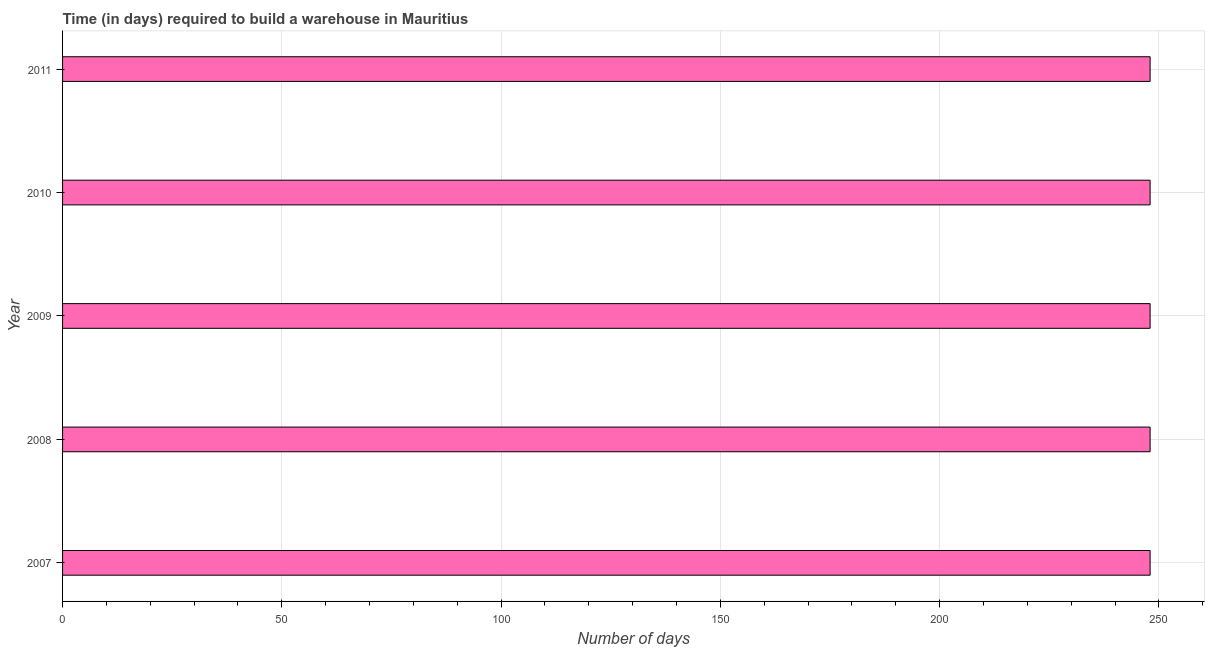Does the graph contain any zero values?
Offer a very short reply. No. Does the graph contain grids?
Offer a very short reply. Yes. What is the title of the graph?
Keep it short and to the point. Time (in days) required to build a warehouse in Mauritius. What is the label or title of the X-axis?
Keep it short and to the point. Number of days. What is the time required to build a warehouse in 2011?
Offer a very short reply. 248. Across all years, what is the maximum time required to build a warehouse?
Offer a terse response. 248. Across all years, what is the minimum time required to build a warehouse?
Your response must be concise. 248. What is the sum of the time required to build a warehouse?
Keep it short and to the point. 1240. What is the difference between the time required to build a warehouse in 2007 and 2009?
Your answer should be compact. 0. What is the average time required to build a warehouse per year?
Your answer should be very brief. 248. What is the median time required to build a warehouse?
Give a very brief answer. 248. Do a majority of the years between 2007 and 2010 (inclusive) have time required to build a warehouse greater than 230 days?
Provide a short and direct response. Yes. What is the ratio of the time required to build a warehouse in 2009 to that in 2011?
Your answer should be compact. 1. Is the difference between the time required to build a warehouse in 2009 and 2011 greater than the difference between any two years?
Give a very brief answer. Yes. Is the sum of the time required to build a warehouse in 2010 and 2011 greater than the maximum time required to build a warehouse across all years?
Ensure brevity in your answer.  Yes. What is the difference between the highest and the lowest time required to build a warehouse?
Offer a very short reply. 0. In how many years, is the time required to build a warehouse greater than the average time required to build a warehouse taken over all years?
Offer a terse response. 0. How many bars are there?
Offer a very short reply. 5. What is the Number of days in 2007?
Your answer should be very brief. 248. What is the Number of days in 2008?
Make the answer very short. 248. What is the Number of days in 2009?
Provide a succinct answer. 248. What is the Number of days of 2010?
Offer a very short reply. 248. What is the Number of days in 2011?
Offer a terse response. 248. What is the difference between the Number of days in 2007 and 2008?
Give a very brief answer. 0. What is the difference between the Number of days in 2007 and 2009?
Make the answer very short. 0. What is the difference between the Number of days in 2007 and 2010?
Make the answer very short. 0. What is the difference between the Number of days in 2007 and 2011?
Your answer should be compact. 0. What is the difference between the Number of days in 2008 and 2009?
Give a very brief answer. 0. What is the difference between the Number of days in 2008 and 2010?
Provide a short and direct response. 0. What is the difference between the Number of days in 2008 and 2011?
Ensure brevity in your answer.  0. What is the difference between the Number of days in 2009 and 2010?
Make the answer very short. 0. What is the difference between the Number of days in 2009 and 2011?
Provide a succinct answer. 0. What is the difference between the Number of days in 2010 and 2011?
Your answer should be compact. 0. What is the ratio of the Number of days in 2007 to that in 2010?
Give a very brief answer. 1. What is the ratio of the Number of days in 2008 to that in 2010?
Your answer should be very brief. 1. What is the ratio of the Number of days in 2008 to that in 2011?
Give a very brief answer. 1. What is the ratio of the Number of days in 2009 to that in 2010?
Provide a succinct answer. 1. 